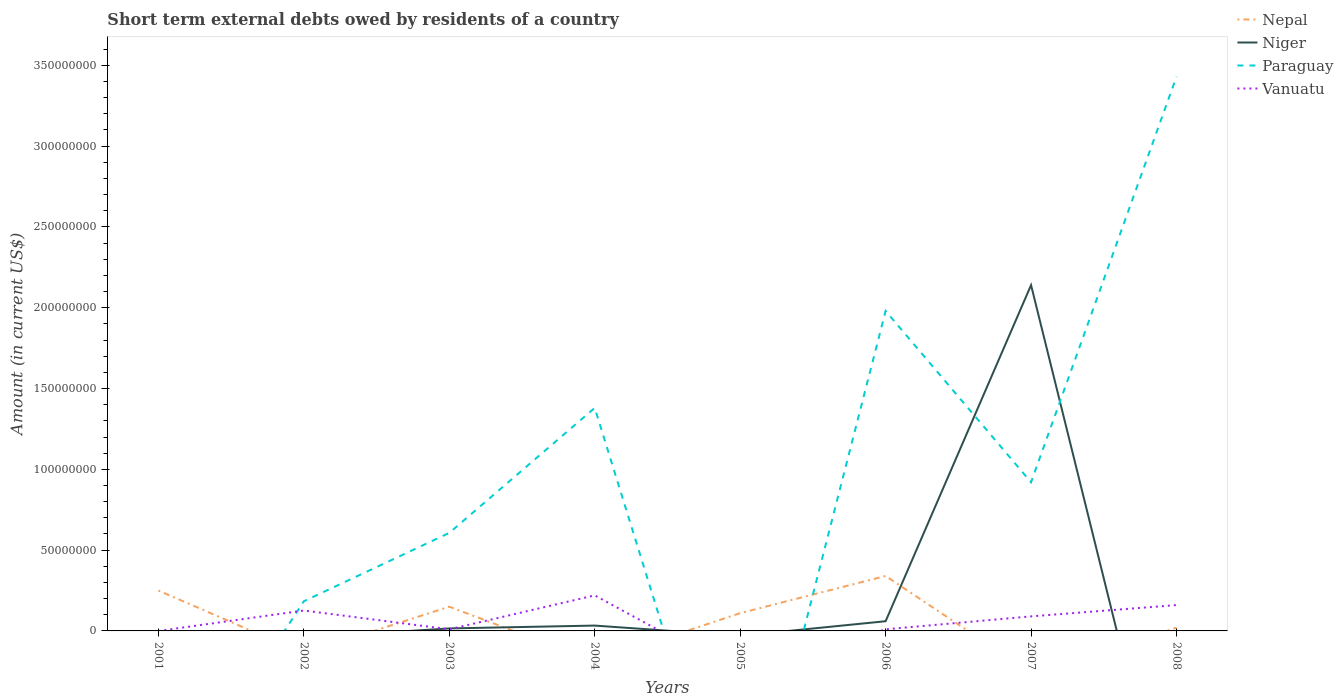How many different coloured lines are there?
Your answer should be compact. 4. Does the line corresponding to Paraguay intersect with the line corresponding to Niger?
Offer a very short reply. Yes. What is the total amount of short-term external debts owed by residents in Nepal in the graph?
Your response must be concise. 1.00e+07. What is the difference between the highest and the second highest amount of short-term external debts owed by residents in Nepal?
Offer a terse response. 3.40e+07. What is the difference between two consecutive major ticks on the Y-axis?
Provide a succinct answer. 5.00e+07. Does the graph contain any zero values?
Offer a very short reply. Yes. Does the graph contain grids?
Give a very brief answer. No. How are the legend labels stacked?
Offer a very short reply. Vertical. What is the title of the graph?
Make the answer very short. Short term external debts owed by residents of a country. Does "Paraguay" appear as one of the legend labels in the graph?
Make the answer very short. Yes. What is the label or title of the X-axis?
Your answer should be very brief. Years. What is the label or title of the Y-axis?
Give a very brief answer. Amount (in current US$). What is the Amount (in current US$) in Nepal in 2001?
Your answer should be very brief. 2.50e+07. What is the Amount (in current US$) in Vanuatu in 2001?
Your response must be concise. 0. What is the Amount (in current US$) in Nepal in 2002?
Provide a short and direct response. 0. What is the Amount (in current US$) of Paraguay in 2002?
Keep it short and to the point. 1.84e+07. What is the Amount (in current US$) of Vanuatu in 2002?
Offer a terse response. 1.26e+07. What is the Amount (in current US$) in Nepal in 2003?
Provide a short and direct response. 1.50e+07. What is the Amount (in current US$) of Niger in 2003?
Your answer should be very brief. 1.54e+06. What is the Amount (in current US$) of Paraguay in 2003?
Make the answer very short. 6.07e+07. What is the Amount (in current US$) in Niger in 2004?
Your answer should be very brief. 3.30e+06. What is the Amount (in current US$) in Paraguay in 2004?
Your answer should be compact. 1.38e+08. What is the Amount (in current US$) of Vanuatu in 2004?
Keep it short and to the point. 2.20e+07. What is the Amount (in current US$) of Nepal in 2005?
Give a very brief answer. 1.10e+07. What is the Amount (in current US$) of Vanuatu in 2005?
Ensure brevity in your answer.  0. What is the Amount (in current US$) of Nepal in 2006?
Offer a terse response. 3.40e+07. What is the Amount (in current US$) of Paraguay in 2006?
Ensure brevity in your answer.  1.98e+08. What is the Amount (in current US$) of Vanuatu in 2006?
Offer a very short reply. 1.00e+06. What is the Amount (in current US$) in Niger in 2007?
Offer a terse response. 2.14e+08. What is the Amount (in current US$) of Paraguay in 2007?
Provide a short and direct response. 9.20e+07. What is the Amount (in current US$) of Vanuatu in 2007?
Ensure brevity in your answer.  9.00e+06. What is the Amount (in current US$) in Niger in 2008?
Offer a very short reply. 0. What is the Amount (in current US$) in Paraguay in 2008?
Your answer should be very brief. 3.43e+08. What is the Amount (in current US$) of Vanuatu in 2008?
Ensure brevity in your answer.  1.60e+07. Across all years, what is the maximum Amount (in current US$) in Nepal?
Provide a succinct answer. 3.40e+07. Across all years, what is the maximum Amount (in current US$) in Niger?
Ensure brevity in your answer.  2.14e+08. Across all years, what is the maximum Amount (in current US$) in Paraguay?
Offer a terse response. 3.43e+08. Across all years, what is the maximum Amount (in current US$) of Vanuatu?
Provide a short and direct response. 2.20e+07. Across all years, what is the minimum Amount (in current US$) of Paraguay?
Your answer should be compact. 0. What is the total Amount (in current US$) of Nepal in the graph?
Your answer should be compact. 8.70e+07. What is the total Amount (in current US$) of Niger in the graph?
Your response must be concise. 2.25e+08. What is the total Amount (in current US$) of Paraguay in the graph?
Ensure brevity in your answer.  8.50e+08. What is the total Amount (in current US$) in Vanuatu in the graph?
Give a very brief answer. 6.16e+07. What is the difference between the Amount (in current US$) of Nepal in 2001 and that in 2003?
Offer a very short reply. 1.00e+07. What is the difference between the Amount (in current US$) of Nepal in 2001 and that in 2005?
Offer a terse response. 1.40e+07. What is the difference between the Amount (in current US$) in Nepal in 2001 and that in 2006?
Offer a very short reply. -9.00e+06. What is the difference between the Amount (in current US$) of Nepal in 2001 and that in 2008?
Make the answer very short. 2.30e+07. What is the difference between the Amount (in current US$) of Paraguay in 2002 and that in 2003?
Offer a very short reply. -4.23e+07. What is the difference between the Amount (in current US$) in Vanuatu in 2002 and that in 2003?
Provide a short and direct response. 1.16e+07. What is the difference between the Amount (in current US$) of Paraguay in 2002 and that in 2004?
Make the answer very short. -1.20e+08. What is the difference between the Amount (in current US$) of Vanuatu in 2002 and that in 2004?
Make the answer very short. -9.37e+06. What is the difference between the Amount (in current US$) in Paraguay in 2002 and that in 2006?
Make the answer very short. -1.80e+08. What is the difference between the Amount (in current US$) of Vanuatu in 2002 and that in 2006?
Your answer should be very brief. 1.16e+07. What is the difference between the Amount (in current US$) of Paraguay in 2002 and that in 2007?
Offer a very short reply. -7.36e+07. What is the difference between the Amount (in current US$) of Vanuatu in 2002 and that in 2007?
Your response must be concise. 3.63e+06. What is the difference between the Amount (in current US$) of Paraguay in 2002 and that in 2008?
Ensure brevity in your answer.  -3.25e+08. What is the difference between the Amount (in current US$) of Vanuatu in 2002 and that in 2008?
Ensure brevity in your answer.  -3.37e+06. What is the difference between the Amount (in current US$) of Niger in 2003 and that in 2004?
Give a very brief answer. -1.76e+06. What is the difference between the Amount (in current US$) of Paraguay in 2003 and that in 2004?
Give a very brief answer. -7.73e+07. What is the difference between the Amount (in current US$) of Vanuatu in 2003 and that in 2004?
Keep it short and to the point. -2.10e+07. What is the difference between the Amount (in current US$) in Nepal in 2003 and that in 2005?
Your response must be concise. 4.00e+06. What is the difference between the Amount (in current US$) of Nepal in 2003 and that in 2006?
Offer a terse response. -1.90e+07. What is the difference between the Amount (in current US$) in Niger in 2003 and that in 2006?
Your answer should be very brief. -4.46e+06. What is the difference between the Amount (in current US$) of Paraguay in 2003 and that in 2006?
Ensure brevity in your answer.  -1.37e+08. What is the difference between the Amount (in current US$) in Niger in 2003 and that in 2007?
Give a very brief answer. -2.12e+08. What is the difference between the Amount (in current US$) of Paraguay in 2003 and that in 2007?
Offer a terse response. -3.13e+07. What is the difference between the Amount (in current US$) of Vanuatu in 2003 and that in 2007?
Your response must be concise. -8.00e+06. What is the difference between the Amount (in current US$) of Nepal in 2003 and that in 2008?
Offer a very short reply. 1.30e+07. What is the difference between the Amount (in current US$) in Paraguay in 2003 and that in 2008?
Make the answer very short. -2.82e+08. What is the difference between the Amount (in current US$) of Vanuatu in 2003 and that in 2008?
Provide a short and direct response. -1.50e+07. What is the difference between the Amount (in current US$) in Niger in 2004 and that in 2006?
Your response must be concise. -2.70e+06. What is the difference between the Amount (in current US$) in Paraguay in 2004 and that in 2006?
Make the answer very short. -6.00e+07. What is the difference between the Amount (in current US$) in Vanuatu in 2004 and that in 2006?
Provide a short and direct response. 2.10e+07. What is the difference between the Amount (in current US$) in Niger in 2004 and that in 2007?
Ensure brevity in your answer.  -2.11e+08. What is the difference between the Amount (in current US$) of Paraguay in 2004 and that in 2007?
Your response must be concise. 4.60e+07. What is the difference between the Amount (in current US$) of Vanuatu in 2004 and that in 2007?
Your answer should be compact. 1.30e+07. What is the difference between the Amount (in current US$) in Paraguay in 2004 and that in 2008?
Your answer should be compact. -2.05e+08. What is the difference between the Amount (in current US$) of Vanuatu in 2004 and that in 2008?
Give a very brief answer. 6.00e+06. What is the difference between the Amount (in current US$) of Nepal in 2005 and that in 2006?
Offer a terse response. -2.30e+07. What is the difference between the Amount (in current US$) of Nepal in 2005 and that in 2008?
Keep it short and to the point. 9.00e+06. What is the difference between the Amount (in current US$) in Niger in 2006 and that in 2007?
Offer a very short reply. -2.08e+08. What is the difference between the Amount (in current US$) in Paraguay in 2006 and that in 2007?
Provide a succinct answer. 1.06e+08. What is the difference between the Amount (in current US$) of Vanuatu in 2006 and that in 2007?
Offer a very short reply. -8.00e+06. What is the difference between the Amount (in current US$) in Nepal in 2006 and that in 2008?
Your answer should be very brief. 3.20e+07. What is the difference between the Amount (in current US$) in Paraguay in 2006 and that in 2008?
Make the answer very short. -1.45e+08. What is the difference between the Amount (in current US$) in Vanuatu in 2006 and that in 2008?
Your response must be concise. -1.50e+07. What is the difference between the Amount (in current US$) in Paraguay in 2007 and that in 2008?
Your answer should be very brief. -2.51e+08. What is the difference between the Amount (in current US$) in Vanuatu in 2007 and that in 2008?
Provide a short and direct response. -7.00e+06. What is the difference between the Amount (in current US$) of Nepal in 2001 and the Amount (in current US$) of Paraguay in 2002?
Provide a succinct answer. 6.64e+06. What is the difference between the Amount (in current US$) in Nepal in 2001 and the Amount (in current US$) in Vanuatu in 2002?
Make the answer very short. 1.24e+07. What is the difference between the Amount (in current US$) in Nepal in 2001 and the Amount (in current US$) in Niger in 2003?
Provide a short and direct response. 2.35e+07. What is the difference between the Amount (in current US$) in Nepal in 2001 and the Amount (in current US$) in Paraguay in 2003?
Offer a terse response. -3.57e+07. What is the difference between the Amount (in current US$) of Nepal in 2001 and the Amount (in current US$) of Vanuatu in 2003?
Your response must be concise. 2.40e+07. What is the difference between the Amount (in current US$) of Nepal in 2001 and the Amount (in current US$) of Niger in 2004?
Ensure brevity in your answer.  2.17e+07. What is the difference between the Amount (in current US$) in Nepal in 2001 and the Amount (in current US$) in Paraguay in 2004?
Ensure brevity in your answer.  -1.13e+08. What is the difference between the Amount (in current US$) in Nepal in 2001 and the Amount (in current US$) in Niger in 2006?
Provide a short and direct response. 1.90e+07. What is the difference between the Amount (in current US$) in Nepal in 2001 and the Amount (in current US$) in Paraguay in 2006?
Keep it short and to the point. -1.73e+08. What is the difference between the Amount (in current US$) of Nepal in 2001 and the Amount (in current US$) of Vanuatu in 2006?
Ensure brevity in your answer.  2.40e+07. What is the difference between the Amount (in current US$) of Nepal in 2001 and the Amount (in current US$) of Niger in 2007?
Offer a very short reply. -1.89e+08. What is the difference between the Amount (in current US$) in Nepal in 2001 and the Amount (in current US$) in Paraguay in 2007?
Provide a succinct answer. -6.70e+07. What is the difference between the Amount (in current US$) in Nepal in 2001 and the Amount (in current US$) in Vanuatu in 2007?
Keep it short and to the point. 1.60e+07. What is the difference between the Amount (in current US$) in Nepal in 2001 and the Amount (in current US$) in Paraguay in 2008?
Your answer should be very brief. -3.18e+08. What is the difference between the Amount (in current US$) in Nepal in 2001 and the Amount (in current US$) in Vanuatu in 2008?
Ensure brevity in your answer.  9.00e+06. What is the difference between the Amount (in current US$) of Paraguay in 2002 and the Amount (in current US$) of Vanuatu in 2003?
Make the answer very short. 1.74e+07. What is the difference between the Amount (in current US$) of Paraguay in 2002 and the Amount (in current US$) of Vanuatu in 2004?
Ensure brevity in your answer.  -3.64e+06. What is the difference between the Amount (in current US$) in Paraguay in 2002 and the Amount (in current US$) in Vanuatu in 2006?
Offer a very short reply. 1.74e+07. What is the difference between the Amount (in current US$) in Paraguay in 2002 and the Amount (in current US$) in Vanuatu in 2007?
Your answer should be compact. 9.36e+06. What is the difference between the Amount (in current US$) in Paraguay in 2002 and the Amount (in current US$) in Vanuatu in 2008?
Provide a short and direct response. 2.36e+06. What is the difference between the Amount (in current US$) in Nepal in 2003 and the Amount (in current US$) in Niger in 2004?
Provide a succinct answer. 1.17e+07. What is the difference between the Amount (in current US$) in Nepal in 2003 and the Amount (in current US$) in Paraguay in 2004?
Keep it short and to the point. -1.23e+08. What is the difference between the Amount (in current US$) of Nepal in 2003 and the Amount (in current US$) of Vanuatu in 2004?
Keep it short and to the point. -7.00e+06. What is the difference between the Amount (in current US$) in Niger in 2003 and the Amount (in current US$) in Paraguay in 2004?
Offer a very short reply. -1.36e+08. What is the difference between the Amount (in current US$) in Niger in 2003 and the Amount (in current US$) in Vanuatu in 2004?
Ensure brevity in your answer.  -2.05e+07. What is the difference between the Amount (in current US$) in Paraguay in 2003 and the Amount (in current US$) in Vanuatu in 2004?
Give a very brief answer. 3.87e+07. What is the difference between the Amount (in current US$) of Nepal in 2003 and the Amount (in current US$) of Niger in 2006?
Keep it short and to the point. 9.00e+06. What is the difference between the Amount (in current US$) of Nepal in 2003 and the Amount (in current US$) of Paraguay in 2006?
Offer a terse response. -1.83e+08. What is the difference between the Amount (in current US$) of Nepal in 2003 and the Amount (in current US$) of Vanuatu in 2006?
Your response must be concise. 1.40e+07. What is the difference between the Amount (in current US$) in Niger in 2003 and the Amount (in current US$) in Paraguay in 2006?
Make the answer very short. -1.96e+08. What is the difference between the Amount (in current US$) in Niger in 2003 and the Amount (in current US$) in Vanuatu in 2006?
Provide a short and direct response. 5.43e+05. What is the difference between the Amount (in current US$) of Paraguay in 2003 and the Amount (in current US$) of Vanuatu in 2006?
Your answer should be very brief. 5.97e+07. What is the difference between the Amount (in current US$) of Nepal in 2003 and the Amount (in current US$) of Niger in 2007?
Offer a very short reply. -1.99e+08. What is the difference between the Amount (in current US$) in Nepal in 2003 and the Amount (in current US$) in Paraguay in 2007?
Provide a succinct answer. -7.70e+07. What is the difference between the Amount (in current US$) in Nepal in 2003 and the Amount (in current US$) in Vanuatu in 2007?
Provide a short and direct response. 6.00e+06. What is the difference between the Amount (in current US$) of Niger in 2003 and the Amount (in current US$) of Paraguay in 2007?
Ensure brevity in your answer.  -9.05e+07. What is the difference between the Amount (in current US$) in Niger in 2003 and the Amount (in current US$) in Vanuatu in 2007?
Give a very brief answer. -7.46e+06. What is the difference between the Amount (in current US$) in Paraguay in 2003 and the Amount (in current US$) in Vanuatu in 2007?
Your answer should be compact. 5.17e+07. What is the difference between the Amount (in current US$) of Nepal in 2003 and the Amount (in current US$) of Paraguay in 2008?
Your answer should be compact. -3.28e+08. What is the difference between the Amount (in current US$) in Niger in 2003 and the Amount (in current US$) in Paraguay in 2008?
Ensure brevity in your answer.  -3.41e+08. What is the difference between the Amount (in current US$) in Niger in 2003 and the Amount (in current US$) in Vanuatu in 2008?
Keep it short and to the point. -1.45e+07. What is the difference between the Amount (in current US$) in Paraguay in 2003 and the Amount (in current US$) in Vanuatu in 2008?
Your answer should be very brief. 4.47e+07. What is the difference between the Amount (in current US$) of Niger in 2004 and the Amount (in current US$) of Paraguay in 2006?
Keep it short and to the point. -1.95e+08. What is the difference between the Amount (in current US$) in Niger in 2004 and the Amount (in current US$) in Vanuatu in 2006?
Your response must be concise. 2.30e+06. What is the difference between the Amount (in current US$) in Paraguay in 2004 and the Amount (in current US$) in Vanuatu in 2006?
Your answer should be compact. 1.37e+08. What is the difference between the Amount (in current US$) in Niger in 2004 and the Amount (in current US$) in Paraguay in 2007?
Provide a short and direct response. -8.87e+07. What is the difference between the Amount (in current US$) of Niger in 2004 and the Amount (in current US$) of Vanuatu in 2007?
Make the answer very short. -5.70e+06. What is the difference between the Amount (in current US$) in Paraguay in 2004 and the Amount (in current US$) in Vanuatu in 2007?
Provide a succinct answer. 1.29e+08. What is the difference between the Amount (in current US$) in Niger in 2004 and the Amount (in current US$) in Paraguay in 2008?
Offer a very short reply. -3.40e+08. What is the difference between the Amount (in current US$) of Niger in 2004 and the Amount (in current US$) of Vanuatu in 2008?
Keep it short and to the point. -1.27e+07. What is the difference between the Amount (in current US$) of Paraguay in 2004 and the Amount (in current US$) of Vanuatu in 2008?
Provide a succinct answer. 1.22e+08. What is the difference between the Amount (in current US$) of Nepal in 2005 and the Amount (in current US$) of Niger in 2006?
Keep it short and to the point. 5.00e+06. What is the difference between the Amount (in current US$) of Nepal in 2005 and the Amount (in current US$) of Paraguay in 2006?
Offer a terse response. -1.87e+08. What is the difference between the Amount (in current US$) of Nepal in 2005 and the Amount (in current US$) of Niger in 2007?
Provide a short and direct response. -2.03e+08. What is the difference between the Amount (in current US$) of Nepal in 2005 and the Amount (in current US$) of Paraguay in 2007?
Provide a succinct answer. -8.10e+07. What is the difference between the Amount (in current US$) of Nepal in 2005 and the Amount (in current US$) of Paraguay in 2008?
Your answer should be very brief. -3.32e+08. What is the difference between the Amount (in current US$) of Nepal in 2005 and the Amount (in current US$) of Vanuatu in 2008?
Your answer should be very brief. -5.00e+06. What is the difference between the Amount (in current US$) in Nepal in 2006 and the Amount (in current US$) in Niger in 2007?
Offer a very short reply. -1.80e+08. What is the difference between the Amount (in current US$) in Nepal in 2006 and the Amount (in current US$) in Paraguay in 2007?
Your response must be concise. -5.80e+07. What is the difference between the Amount (in current US$) in Nepal in 2006 and the Amount (in current US$) in Vanuatu in 2007?
Provide a short and direct response. 2.50e+07. What is the difference between the Amount (in current US$) in Niger in 2006 and the Amount (in current US$) in Paraguay in 2007?
Your answer should be compact. -8.60e+07. What is the difference between the Amount (in current US$) in Niger in 2006 and the Amount (in current US$) in Vanuatu in 2007?
Your answer should be compact. -3.00e+06. What is the difference between the Amount (in current US$) in Paraguay in 2006 and the Amount (in current US$) in Vanuatu in 2007?
Your answer should be very brief. 1.89e+08. What is the difference between the Amount (in current US$) in Nepal in 2006 and the Amount (in current US$) in Paraguay in 2008?
Your answer should be compact. -3.09e+08. What is the difference between the Amount (in current US$) in Nepal in 2006 and the Amount (in current US$) in Vanuatu in 2008?
Provide a short and direct response. 1.80e+07. What is the difference between the Amount (in current US$) in Niger in 2006 and the Amount (in current US$) in Paraguay in 2008?
Give a very brief answer. -3.37e+08. What is the difference between the Amount (in current US$) in Niger in 2006 and the Amount (in current US$) in Vanuatu in 2008?
Your response must be concise. -1.00e+07. What is the difference between the Amount (in current US$) in Paraguay in 2006 and the Amount (in current US$) in Vanuatu in 2008?
Keep it short and to the point. 1.82e+08. What is the difference between the Amount (in current US$) of Niger in 2007 and the Amount (in current US$) of Paraguay in 2008?
Give a very brief answer. -1.29e+08. What is the difference between the Amount (in current US$) of Niger in 2007 and the Amount (in current US$) of Vanuatu in 2008?
Provide a succinct answer. 1.98e+08. What is the difference between the Amount (in current US$) in Paraguay in 2007 and the Amount (in current US$) in Vanuatu in 2008?
Offer a very short reply. 7.60e+07. What is the average Amount (in current US$) in Nepal per year?
Keep it short and to the point. 1.09e+07. What is the average Amount (in current US$) in Niger per year?
Your answer should be very brief. 2.81e+07. What is the average Amount (in current US$) of Paraguay per year?
Provide a succinct answer. 1.06e+08. What is the average Amount (in current US$) of Vanuatu per year?
Keep it short and to the point. 7.70e+06. In the year 2002, what is the difference between the Amount (in current US$) of Paraguay and Amount (in current US$) of Vanuatu?
Make the answer very short. 5.73e+06. In the year 2003, what is the difference between the Amount (in current US$) of Nepal and Amount (in current US$) of Niger?
Your answer should be very brief. 1.35e+07. In the year 2003, what is the difference between the Amount (in current US$) of Nepal and Amount (in current US$) of Paraguay?
Make the answer very short. -4.57e+07. In the year 2003, what is the difference between the Amount (in current US$) of Nepal and Amount (in current US$) of Vanuatu?
Ensure brevity in your answer.  1.40e+07. In the year 2003, what is the difference between the Amount (in current US$) of Niger and Amount (in current US$) of Paraguay?
Give a very brief answer. -5.91e+07. In the year 2003, what is the difference between the Amount (in current US$) of Niger and Amount (in current US$) of Vanuatu?
Ensure brevity in your answer.  5.43e+05. In the year 2003, what is the difference between the Amount (in current US$) in Paraguay and Amount (in current US$) in Vanuatu?
Make the answer very short. 5.97e+07. In the year 2004, what is the difference between the Amount (in current US$) in Niger and Amount (in current US$) in Paraguay?
Your answer should be compact. -1.35e+08. In the year 2004, what is the difference between the Amount (in current US$) of Niger and Amount (in current US$) of Vanuatu?
Keep it short and to the point. -1.87e+07. In the year 2004, what is the difference between the Amount (in current US$) of Paraguay and Amount (in current US$) of Vanuatu?
Keep it short and to the point. 1.16e+08. In the year 2006, what is the difference between the Amount (in current US$) of Nepal and Amount (in current US$) of Niger?
Keep it short and to the point. 2.80e+07. In the year 2006, what is the difference between the Amount (in current US$) of Nepal and Amount (in current US$) of Paraguay?
Give a very brief answer. -1.64e+08. In the year 2006, what is the difference between the Amount (in current US$) of Nepal and Amount (in current US$) of Vanuatu?
Offer a terse response. 3.30e+07. In the year 2006, what is the difference between the Amount (in current US$) in Niger and Amount (in current US$) in Paraguay?
Your answer should be very brief. -1.92e+08. In the year 2006, what is the difference between the Amount (in current US$) in Niger and Amount (in current US$) in Vanuatu?
Provide a short and direct response. 5.00e+06. In the year 2006, what is the difference between the Amount (in current US$) of Paraguay and Amount (in current US$) of Vanuatu?
Offer a terse response. 1.97e+08. In the year 2007, what is the difference between the Amount (in current US$) in Niger and Amount (in current US$) in Paraguay?
Your answer should be very brief. 1.22e+08. In the year 2007, what is the difference between the Amount (in current US$) in Niger and Amount (in current US$) in Vanuatu?
Make the answer very short. 2.05e+08. In the year 2007, what is the difference between the Amount (in current US$) of Paraguay and Amount (in current US$) of Vanuatu?
Give a very brief answer. 8.30e+07. In the year 2008, what is the difference between the Amount (in current US$) in Nepal and Amount (in current US$) in Paraguay?
Offer a terse response. -3.41e+08. In the year 2008, what is the difference between the Amount (in current US$) of Nepal and Amount (in current US$) of Vanuatu?
Your response must be concise. -1.40e+07. In the year 2008, what is the difference between the Amount (in current US$) in Paraguay and Amount (in current US$) in Vanuatu?
Ensure brevity in your answer.  3.27e+08. What is the ratio of the Amount (in current US$) in Nepal in 2001 to that in 2005?
Offer a very short reply. 2.27. What is the ratio of the Amount (in current US$) of Nepal in 2001 to that in 2006?
Keep it short and to the point. 0.74. What is the ratio of the Amount (in current US$) of Paraguay in 2002 to that in 2003?
Provide a short and direct response. 0.3. What is the ratio of the Amount (in current US$) in Vanuatu in 2002 to that in 2003?
Offer a very short reply. 12.63. What is the ratio of the Amount (in current US$) of Paraguay in 2002 to that in 2004?
Give a very brief answer. 0.13. What is the ratio of the Amount (in current US$) of Vanuatu in 2002 to that in 2004?
Your answer should be very brief. 0.57. What is the ratio of the Amount (in current US$) of Paraguay in 2002 to that in 2006?
Offer a very short reply. 0.09. What is the ratio of the Amount (in current US$) in Vanuatu in 2002 to that in 2006?
Your answer should be very brief. 12.63. What is the ratio of the Amount (in current US$) in Paraguay in 2002 to that in 2007?
Provide a succinct answer. 0.2. What is the ratio of the Amount (in current US$) of Vanuatu in 2002 to that in 2007?
Your response must be concise. 1.4. What is the ratio of the Amount (in current US$) in Paraguay in 2002 to that in 2008?
Offer a terse response. 0.05. What is the ratio of the Amount (in current US$) in Vanuatu in 2002 to that in 2008?
Your answer should be compact. 0.79. What is the ratio of the Amount (in current US$) of Niger in 2003 to that in 2004?
Your response must be concise. 0.47. What is the ratio of the Amount (in current US$) of Paraguay in 2003 to that in 2004?
Ensure brevity in your answer.  0.44. What is the ratio of the Amount (in current US$) in Vanuatu in 2003 to that in 2004?
Provide a succinct answer. 0.05. What is the ratio of the Amount (in current US$) in Nepal in 2003 to that in 2005?
Your answer should be compact. 1.36. What is the ratio of the Amount (in current US$) in Nepal in 2003 to that in 2006?
Offer a very short reply. 0.44. What is the ratio of the Amount (in current US$) in Niger in 2003 to that in 2006?
Offer a very short reply. 0.26. What is the ratio of the Amount (in current US$) of Paraguay in 2003 to that in 2006?
Ensure brevity in your answer.  0.31. What is the ratio of the Amount (in current US$) in Niger in 2003 to that in 2007?
Make the answer very short. 0.01. What is the ratio of the Amount (in current US$) of Paraguay in 2003 to that in 2007?
Provide a short and direct response. 0.66. What is the ratio of the Amount (in current US$) of Paraguay in 2003 to that in 2008?
Your response must be concise. 0.18. What is the ratio of the Amount (in current US$) in Vanuatu in 2003 to that in 2008?
Provide a succinct answer. 0.06. What is the ratio of the Amount (in current US$) in Niger in 2004 to that in 2006?
Offer a terse response. 0.55. What is the ratio of the Amount (in current US$) in Paraguay in 2004 to that in 2006?
Offer a very short reply. 0.7. What is the ratio of the Amount (in current US$) of Niger in 2004 to that in 2007?
Make the answer very short. 0.02. What is the ratio of the Amount (in current US$) of Vanuatu in 2004 to that in 2007?
Your response must be concise. 2.44. What is the ratio of the Amount (in current US$) of Paraguay in 2004 to that in 2008?
Offer a terse response. 0.4. What is the ratio of the Amount (in current US$) in Vanuatu in 2004 to that in 2008?
Offer a very short reply. 1.38. What is the ratio of the Amount (in current US$) of Nepal in 2005 to that in 2006?
Ensure brevity in your answer.  0.32. What is the ratio of the Amount (in current US$) of Niger in 2006 to that in 2007?
Give a very brief answer. 0.03. What is the ratio of the Amount (in current US$) in Paraguay in 2006 to that in 2007?
Ensure brevity in your answer.  2.15. What is the ratio of the Amount (in current US$) of Vanuatu in 2006 to that in 2007?
Provide a short and direct response. 0.11. What is the ratio of the Amount (in current US$) in Nepal in 2006 to that in 2008?
Offer a very short reply. 17. What is the ratio of the Amount (in current US$) in Paraguay in 2006 to that in 2008?
Give a very brief answer. 0.58. What is the ratio of the Amount (in current US$) of Vanuatu in 2006 to that in 2008?
Your answer should be very brief. 0.06. What is the ratio of the Amount (in current US$) of Paraguay in 2007 to that in 2008?
Your response must be concise. 0.27. What is the ratio of the Amount (in current US$) of Vanuatu in 2007 to that in 2008?
Your answer should be compact. 0.56. What is the difference between the highest and the second highest Amount (in current US$) of Nepal?
Your response must be concise. 9.00e+06. What is the difference between the highest and the second highest Amount (in current US$) in Niger?
Make the answer very short. 2.08e+08. What is the difference between the highest and the second highest Amount (in current US$) in Paraguay?
Your answer should be compact. 1.45e+08. What is the difference between the highest and the second highest Amount (in current US$) of Vanuatu?
Give a very brief answer. 6.00e+06. What is the difference between the highest and the lowest Amount (in current US$) of Nepal?
Your answer should be compact. 3.40e+07. What is the difference between the highest and the lowest Amount (in current US$) of Niger?
Provide a succinct answer. 2.14e+08. What is the difference between the highest and the lowest Amount (in current US$) in Paraguay?
Give a very brief answer. 3.43e+08. What is the difference between the highest and the lowest Amount (in current US$) of Vanuatu?
Your response must be concise. 2.20e+07. 